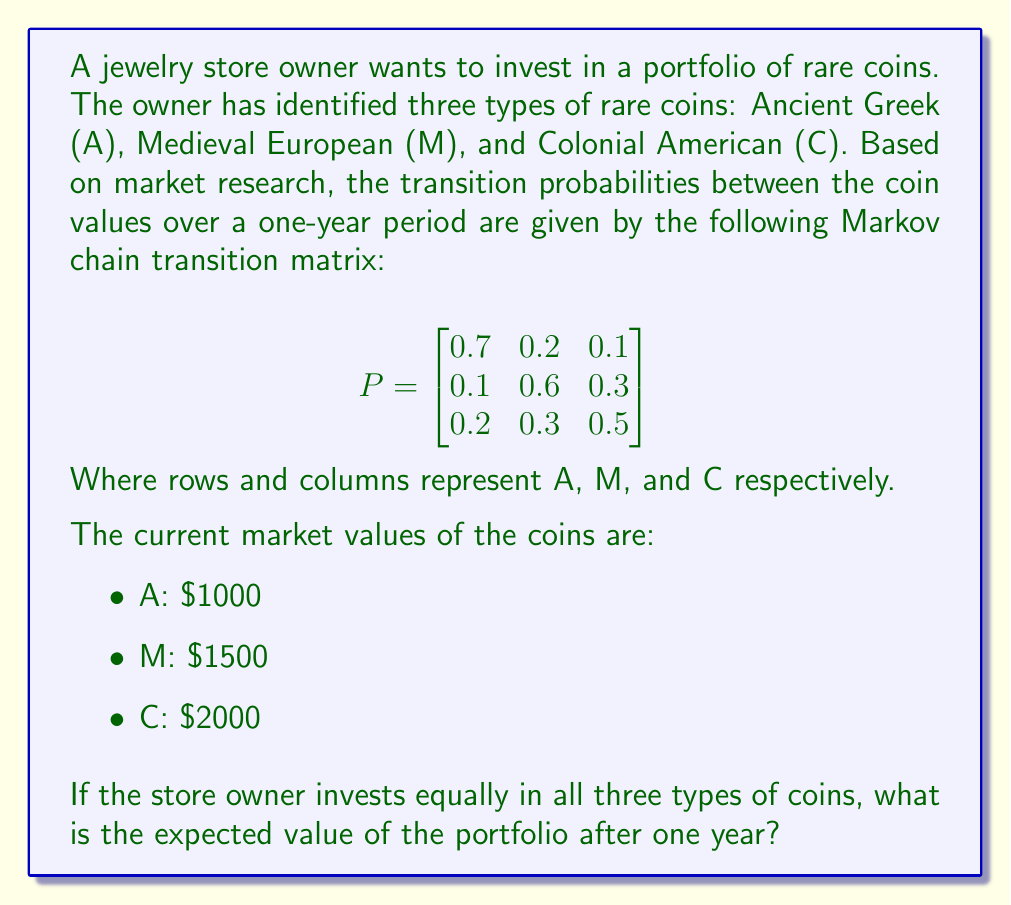Teach me how to tackle this problem. To solve this problem, we need to follow these steps:

1) First, let's calculate the initial state vector. Since the owner invests equally in all three types of coins, the initial state vector is:

   $$\pi_0 = \begin{bmatrix} \frac{1}{3} & \frac{1}{3} & \frac{1}{3} \end{bmatrix}$$

2) To find the state vector after one year, we multiply the initial state vector by the transition matrix:

   $$\pi_1 = \pi_0 P = \begin{bmatrix} \frac{1}{3} & \frac{1}{3} & \frac{1}{3} \end{bmatrix} \begin{bmatrix}
   0.7 & 0.2 & 0.1 \\
   0.1 & 0.6 & 0.3 \\
   0.2 & 0.3 & 0.5
   \end{bmatrix}$$

3) Calculating this:

   $$\pi_1 = \begin{bmatrix} \frac{1}{3}(0.7) + \frac{1}{3}(0.1) + \frac{1}{3}(0.2) & \frac{1}{3}(0.2) + \frac{1}{3}(0.6) + \frac{1}{3}(0.3) & \frac{1}{3}(0.1) + \frac{1}{3}(0.3) + \frac{1}{3}(0.5) \end{bmatrix}$$

   $$\pi_1 = \begin{bmatrix} \frac{1}{3} & \frac{11}{30} & \frac{3}{10} \end{bmatrix}$$

4) Now, to calculate the expected value, we multiply each probability by its corresponding coin value and sum:

   $E = \frac{1}{3} \cdot 1000 + \frac{11}{30} \cdot 1500 + \frac{3}{10} \cdot 2000$

5) Calculating this:

   $E = 333.33 + 550 + 600 = 1483.33$

Therefore, the expected value of the portfolio after one year is $1483.33.
Answer: $1483.33 